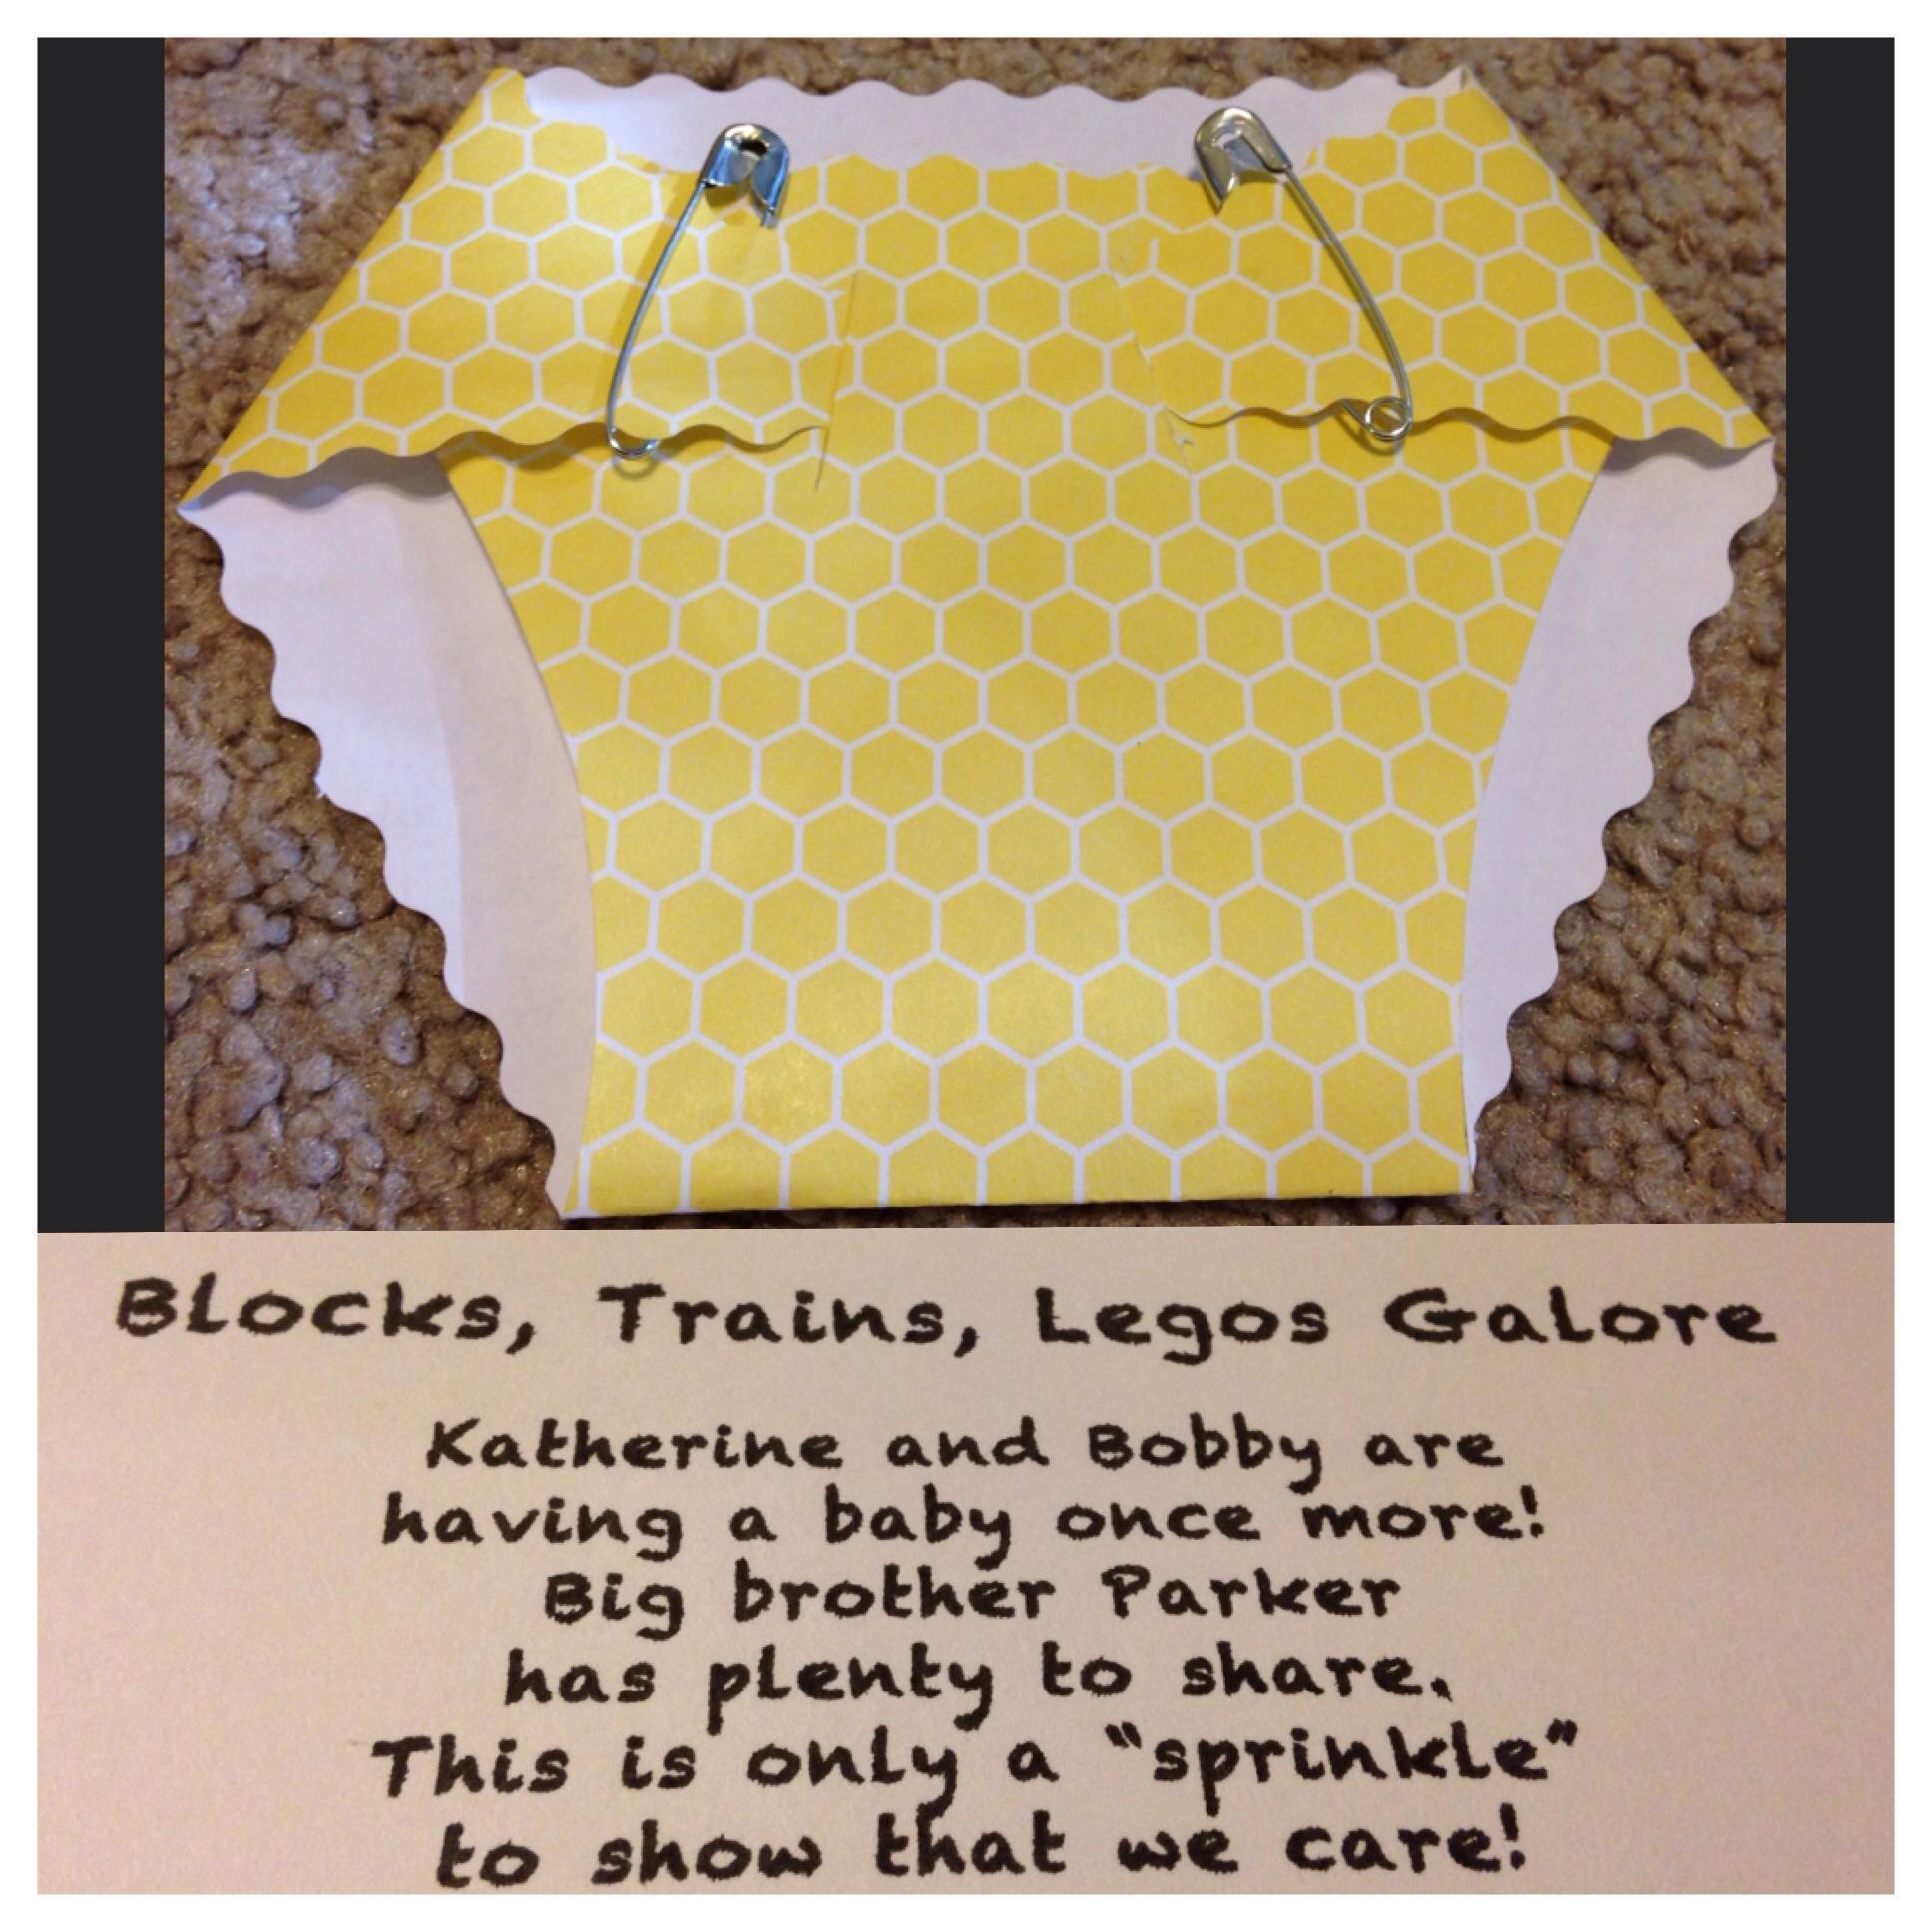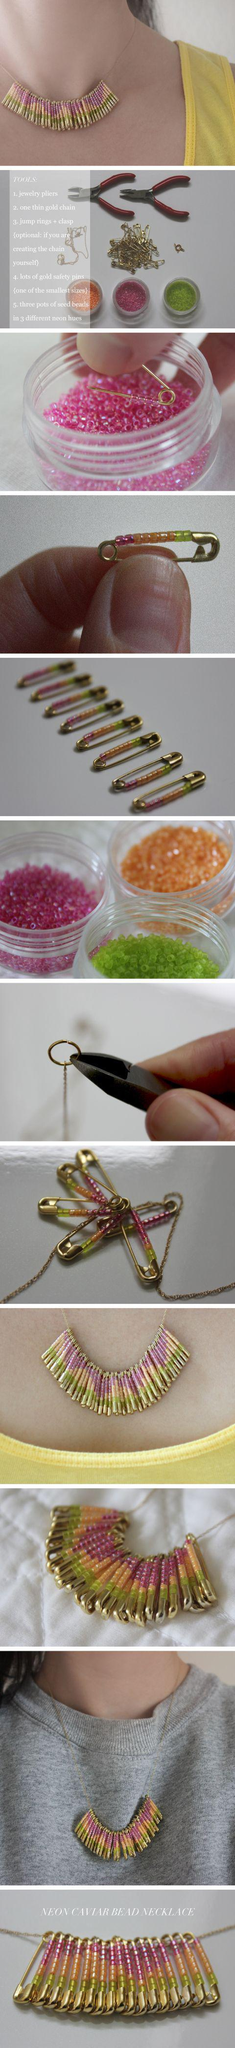The first image is the image on the left, the second image is the image on the right. Assess this claim about the two images: "Some safety pins are strung with beads that create heart shapes.". Correct or not? Answer yes or no. No. The first image is the image on the left, the second image is the image on the right. For the images shown, is this caption "The pins in the image on the left show hearts." true? Answer yes or no. No. 